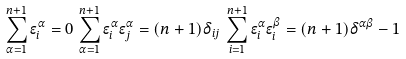<formula> <loc_0><loc_0><loc_500><loc_500>\sum _ { \alpha = 1 } ^ { n + 1 } \epsilon _ { i } ^ { \alpha } = 0 \, \sum _ { \alpha = 1 } ^ { n + 1 } \epsilon _ { i } ^ { \alpha } \epsilon _ { j } ^ { \alpha } = ( n + 1 ) \delta _ { i j } \, \sum _ { i = 1 } ^ { n + 1 } \epsilon _ { i } ^ { \alpha } \epsilon _ { i } ^ { \beta } = ( n + 1 ) \delta ^ { \alpha \beta } - 1</formula> 